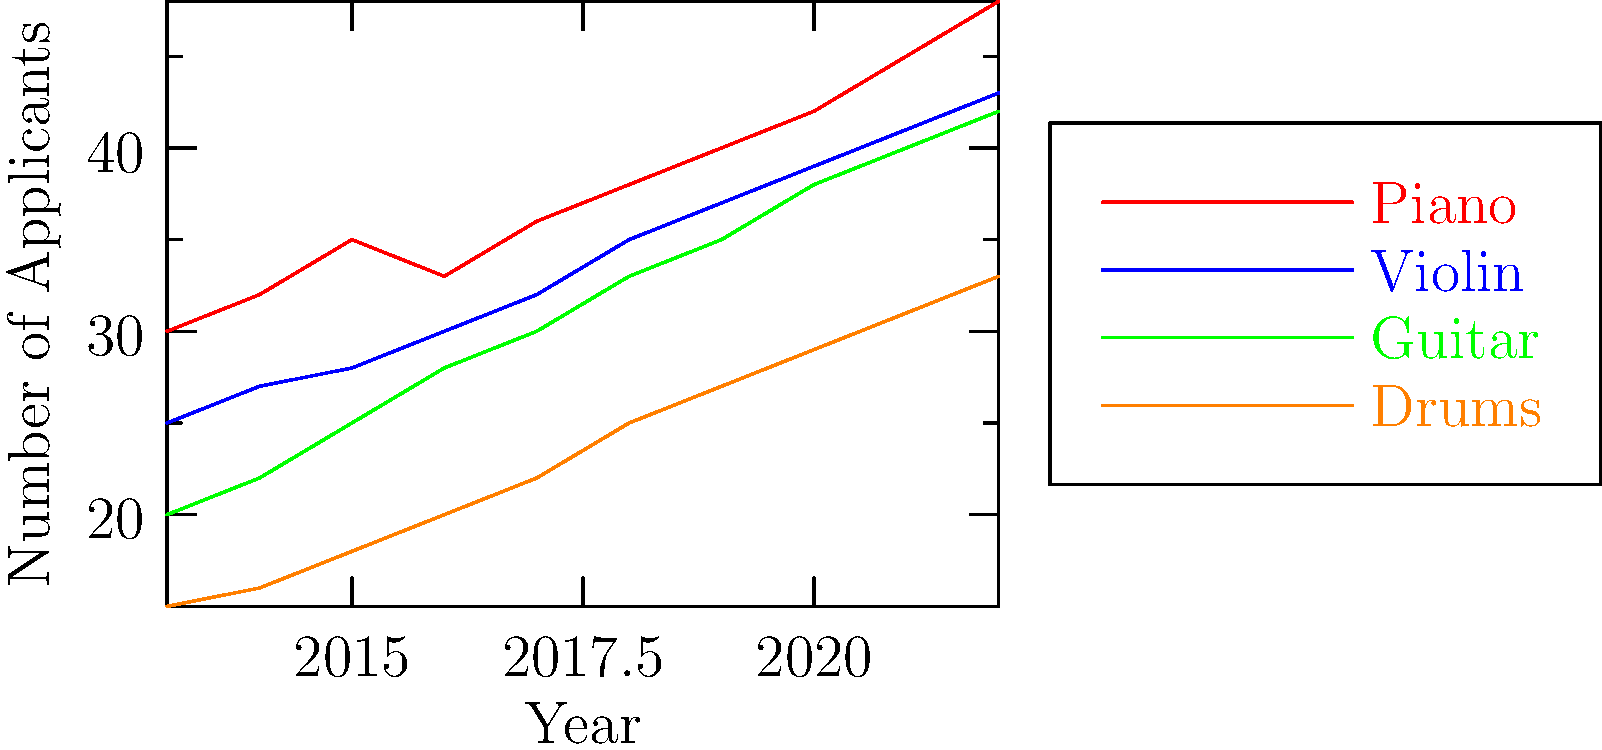Based on the graph showing the distribution of instrument preferences among applicants over the past decade, which instrument has consistently maintained the highest number of applicants, and what is the approximate percentage increase in its applicants from 2013 to 2022? To answer this question, we need to follow these steps:

1. Identify the instrument with the highest number of applicants throughout the decade:
   Looking at the graph, we can see that the red line (Piano) is consistently at the top for all years.

2. Calculate the percentage increase in Piano applicants from 2013 to 2022:
   a) Number of Piano applicants in 2013: 30
   b) Number of Piano applicants in 2022: 48
   c) Increase in applicants: 48 - 30 = 18
   d) Percentage increase: $(18 / 30) \times 100 = 60\%$

Therefore, the Piano has consistently maintained the highest number of applicants, with an approximate percentage increase of 60% from 2013 to 2022.
Answer: Piano, 60% 